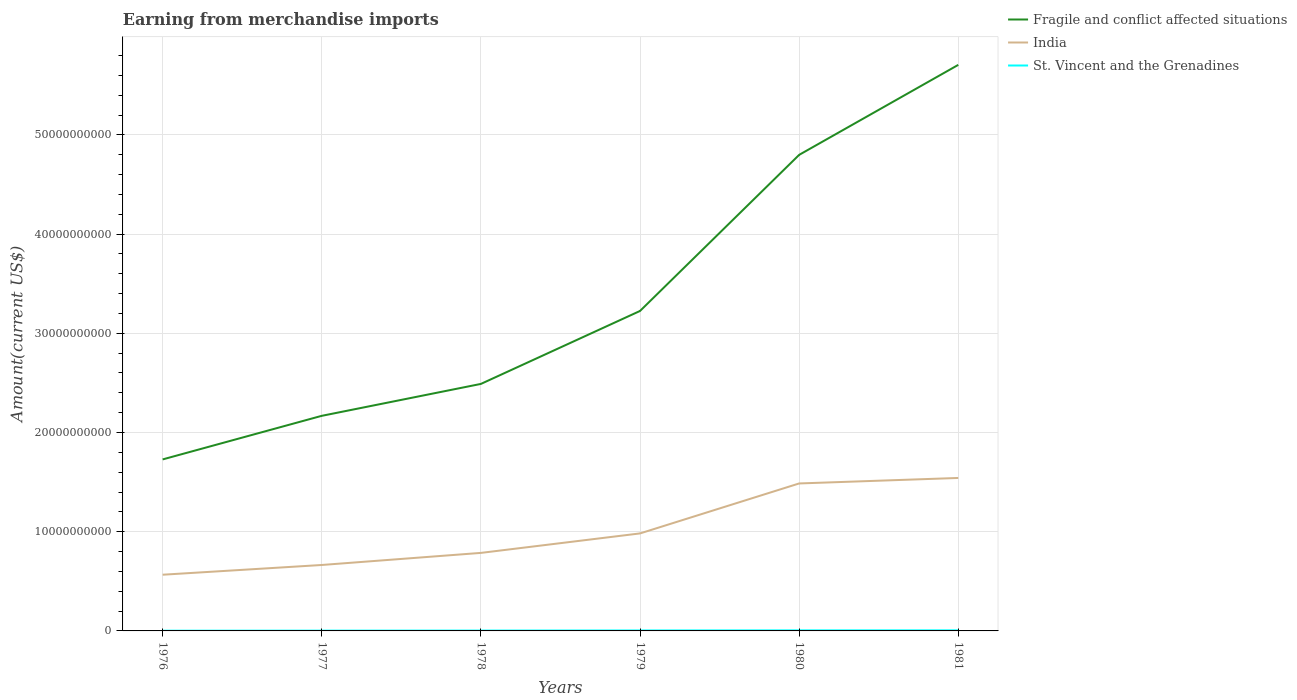Does the line corresponding to St. Vincent and the Grenadines intersect with the line corresponding to India?
Your response must be concise. No. Is the number of lines equal to the number of legend labels?
Provide a succinct answer. Yes. Across all years, what is the maximum amount earned from merchandise imports in St. Vincent and the Grenadines?
Provide a succinct answer. 2.37e+07. In which year was the amount earned from merchandise imports in India maximum?
Make the answer very short. 1976. What is the total amount earned from merchandise imports in St. Vincent and the Grenadines in the graph?
Your response must be concise. -2.77e+07. What is the difference between the highest and the second highest amount earned from merchandise imports in St. Vincent and the Grenadines?
Offer a terse response. 3.43e+07. How many lines are there?
Give a very brief answer. 3. How many years are there in the graph?
Offer a very short reply. 6. Are the values on the major ticks of Y-axis written in scientific E-notation?
Make the answer very short. No. Where does the legend appear in the graph?
Give a very brief answer. Top right. How many legend labels are there?
Offer a terse response. 3. What is the title of the graph?
Your answer should be compact. Earning from merchandise imports. Does "Poland" appear as one of the legend labels in the graph?
Offer a terse response. No. What is the label or title of the Y-axis?
Give a very brief answer. Amount(current US$). What is the Amount(current US$) of Fragile and conflict affected situations in 1976?
Your response must be concise. 1.73e+1. What is the Amount(current US$) of India in 1976?
Offer a very short reply. 5.66e+09. What is the Amount(current US$) of St. Vincent and the Grenadines in 1976?
Your answer should be very brief. 2.37e+07. What is the Amount(current US$) in Fragile and conflict affected situations in 1977?
Give a very brief answer. 2.17e+1. What is the Amount(current US$) of India in 1977?
Make the answer very short. 6.65e+09. What is the Amount(current US$) in St. Vincent and the Grenadines in 1977?
Your answer should be compact. 3.03e+07. What is the Amount(current US$) of Fragile and conflict affected situations in 1978?
Your response must be concise. 2.49e+1. What is the Amount(current US$) of India in 1978?
Provide a succinct answer. 7.86e+09. What is the Amount(current US$) in St. Vincent and the Grenadines in 1978?
Your response must be concise. 3.62e+07. What is the Amount(current US$) of Fragile and conflict affected situations in 1979?
Provide a succinct answer. 3.23e+1. What is the Amount(current US$) in India in 1979?
Your answer should be compact. 9.83e+09. What is the Amount(current US$) in St. Vincent and the Grenadines in 1979?
Provide a succinct answer. 4.66e+07. What is the Amount(current US$) of Fragile and conflict affected situations in 1980?
Make the answer very short. 4.80e+1. What is the Amount(current US$) in India in 1980?
Give a very brief answer. 1.49e+1. What is the Amount(current US$) of St. Vincent and the Grenadines in 1980?
Give a very brief answer. 5.70e+07. What is the Amount(current US$) of Fragile and conflict affected situations in 1981?
Make the answer very short. 5.71e+1. What is the Amount(current US$) in India in 1981?
Offer a terse response. 1.54e+1. What is the Amount(current US$) of St. Vincent and the Grenadines in 1981?
Your response must be concise. 5.80e+07. Across all years, what is the maximum Amount(current US$) of Fragile and conflict affected situations?
Provide a short and direct response. 5.71e+1. Across all years, what is the maximum Amount(current US$) in India?
Your answer should be very brief. 1.54e+1. Across all years, what is the maximum Amount(current US$) in St. Vincent and the Grenadines?
Provide a succinct answer. 5.80e+07. Across all years, what is the minimum Amount(current US$) in Fragile and conflict affected situations?
Your answer should be compact. 1.73e+1. Across all years, what is the minimum Amount(current US$) in India?
Keep it short and to the point. 5.66e+09. Across all years, what is the minimum Amount(current US$) of St. Vincent and the Grenadines?
Provide a short and direct response. 2.37e+07. What is the total Amount(current US$) in Fragile and conflict affected situations in the graph?
Offer a very short reply. 2.01e+11. What is the total Amount(current US$) of India in the graph?
Ensure brevity in your answer.  6.03e+1. What is the total Amount(current US$) in St. Vincent and the Grenadines in the graph?
Keep it short and to the point. 2.52e+08. What is the difference between the Amount(current US$) of Fragile and conflict affected situations in 1976 and that in 1977?
Provide a succinct answer. -4.39e+09. What is the difference between the Amount(current US$) of India in 1976 and that in 1977?
Provide a succinct answer. -9.82e+08. What is the difference between the Amount(current US$) of St. Vincent and the Grenadines in 1976 and that in 1977?
Ensure brevity in your answer.  -6.61e+06. What is the difference between the Amount(current US$) in Fragile and conflict affected situations in 1976 and that in 1978?
Your response must be concise. -7.61e+09. What is the difference between the Amount(current US$) in India in 1976 and that in 1978?
Give a very brief answer. -2.20e+09. What is the difference between the Amount(current US$) of St. Vincent and the Grenadines in 1976 and that in 1978?
Ensure brevity in your answer.  -1.25e+07. What is the difference between the Amount(current US$) of Fragile and conflict affected situations in 1976 and that in 1979?
Make the answer very short. -1.50e+1. What is the difference between the Amount(current US$) of India in 1976 and that in 1979?
Keep it short and to the point. -4.16e+09. What is the difference between the Amount(current US$) of St. Vincent and the Grenadines in 1976 and that in 1979?
Make the answer very short. -2.29e+07. What is the difference between the Amount(current US$) in Fragile and conflict affected situations in 1976 and that in 1980?
Provide a short and direct response. -3.07e+1. What is the difference between the Amount(current US$) of India in 1976 and that in 1980?
Give a very brief answer. -9.20e+09. What is the difference between the Amount(current US$) in St. Vincent and the Grenadines in 1976 and that in 1980?
Your answer should be very brief. -3.33e+07. What is the difference between the Amount(current US$) of Fragile and conflict affected situations in 1976 and that in 1981?
Keep it short and to the point. -3.98e+1. What is the difference between the Amount(current US$) in India in 1976 and that in 1981?
Make the answer very short. -9.75e+09. What is the difference between the Amount(current US$) of St. Vincent and the Grenadines in 1976 and that in 1981?
Your answer should be very brief. -3.43e+07. What is the difference between the Amount(current US$) in Fragile and conflict affected situations in 1977 and that in 1978?
Provide a succinct answer. -3.22e+09. What is the difference between the Amount(current US$) of India in 1977 and that in 1978?
Make the answer very short. -1.22e+09. What is the difference between the Amount(current US$) of St. Vincent and the Grenadines in 1977 and that in 1978?
Offer a terse response. -5.85e+06. What is the difference between the Amount(current US$) in Fragile and conflict affected situations in 1977 and that in 1979?
Your answer should be compact. -1.06e+1. What is the difference between the Amount(current US$) of India in 1977 and that in 1979?
Make the answer very short. -3.18e+09. What is the difference between the Amount(current US$) of St. Vincent and the Grenadines in 1977 and that in 1979?
Offer a terse response. -1.63e+07. What is the difference between the Amount(current US$) in Fragile and conflict affected situations in 1977 and that in 1980?
Ensure brevity in your answer.  -2.63e+1. What is the difference between the Amount(current US$) of India in 1977 and that in 1980?
Give a very brief answer. -8.22e+09. What is the difference between the Amount(current US$) of St. Vincent and the Grenadines in 1977 and that in 1980?
Give a very brief answer. -2.67e+07. What is the difference between the Amount(current US$) of Fragile and conflict affected situations in 1977 and that in 1981?
Your answer should be very brief. -3.54e+1. What is the difference between the Amount(current US$) in India in 1977 and that in 1981?
Provide a succinct answer. -8.77e+09. What is the difference between the Amount(current US$) of St. Vincent and the Grenadines in 1977 and that in 1981?
Offer a terse response. -2.77e+07. What is the difference between the Amount(current US$) in Fragile and conflict affected situations in 1978 and that in 1979?
Provide a succinct answer. -7.35e+09. What is the difference between the Amount(current US$) of India in 1978 and that in 1979?
Make the answer very short. -1.96e+09. What is the difference between the Amount(current US$) of St. Vincent and the Grenadines in 1978 and that in 1979?
Your answer should be compact. -1.04e+07. What is the difference between the Amount(current US$) in Fragile and conflict affected situations in 1978 and that in 1980?
Ensure brevity in your answer.  -2.31e+1. What is the difference between the Amount(current US$) of India in 1978 and that in 1980?
Give a very brief answer. -7.00e+09. What is the difference between the Amount(current US$) of St. Vincent and the Grenadines in 1978 and that in 1980?
Keep it short and to the point. -2.08e+07. What is the difference between the Amount(current US$) in Fragile and conflict affected situations in 1978 and that in 1981?
Provide a short and direct response. -3.22e+1. What is the difference between the Amount(current US$) in India in 1978 and that in 1981?
Provide a succinct answer. -7.55e+09. What is the difference between the Amount(current US$) in St. Vincent and the Grenadines in 1978 and that in 1981?
Ensure brevity in your answer.  -2.18e+07. What is the difference between the Amount(current US$) in Fragile and conflict affected situations in 1979 and that in 1980?
Ensure brevity in your answer.  -1.57e+1. What is the difference between the Amount(current US$) of India in 1979 and that in 1980?
Make the answer very short. -5.04e+09. What is the difference between the Amount(current US$) in St. Vincent and the Grenadines in 1979 and that in 1980?
Your response must be concise. -1.04e+07. What is the difference between the Amount(current US$) of Fragile and conflict affected situations in 1979 and that in 1981?
Keep it short and to the point. -2.48e+1. What is the difference between the Amount(current US$) in India in 1979 and that in 1981?
Your answer should be compact. -5.59e+09. What is the difference between the Amount(current US$) in St. Vincent and the Grenadines in 1979 and that in 1981?
Offer a terse response. -1.14e+07. What is the difference between the Amount(current US$) in Fragile and conflict affected situations in 1980 and that in 1981?
Provide a succinct answer. -9.07e+09. What is the difference between the Amount(current US$) of India in 1980 and that in 1981?
Your response must be concise. -5.54e+08. What is the difference between the Amount(current US$) of St. Vincent and the Grenadines in 1980 and that in 1981?
Offer a very short reply. -1.00e+06. What is the difference between the Amount(current US$) of Fragile and conflict affected situations in 1976 and the Amount(current US$) of India in 1977?
Provide a short and direct response. 1.06e+1. What is the difference between the Amount(current US$) of Fragile and conflict affected situations in 1976 and the Amount(current US$) of St. Vincent and the Grenadines in 1977?
Provide a succinct answer. 1.73e+1. What is the difference between the Amount(current US$) in India in 1976 and the Amount(current US$) in St. Vincent and the Grenadines in 1977?
Offer a terse response. 5.63e+09. What is the difference between the Amount(current US$) of Fragile and conflict affected situations in 1976 and the Amount(current US$) of India in 1978?
Offer a terse response. 9.42e+09. What is the difference between the Amount(current US$) of Fragile and conflict affected situations in 1976 and the Amount(current US$) of St. Vincent and the Grenadines in 1978?
Offer a very short reply. 1.73e+1. What is the difference between the Amount(current US$) in India in 1976 and the Amount(current US$) in St. Vincent and the Grenadines in 1978?
Make the answer very short. 5.63e+09. What is the difference between the Amount(current US$) in Fragile and conflict affected situations in 1976 and the Amount(current US$) in India in 1979?
Your answer should be very brief. 7.46e+09. What is the difference between the Amount(current US$) in Fragile and conflict affected situations in 1976 and the Amount(current US$) in St. Vincent and the Grenadines in 1979?
Provide a short and direct response. 1.72e+1. What is the difference between the Amount(current US$) of India in 1976 and the Amount(current US$) of St. Vincent and the Grenadines in 1979?
Keep it short and to the point. 5.62e+09. What is the difference between the Amount(current US$) of Fragile and conflict affected situations in 1976 and the Amount(current US$) of India in 1980?
Give a very brief answer. 2.42e+09. What is the difference between the Amount(current US$) of Fragile and conflict affected situations in 1976 and the Amount(current US$) of St. Vincent and the Grenadines in 1980?
Your response must be concise. 1.72e+1. What is the difference between the Amount(current US$) in India in 1976 and the Amount(current US$) in St. Vincent and the Grenadines in 1980?
Ensure brevity in your answer.  5.61e+09. What is the difference between the Amount(current US$) of Fragile and conflict affected situations in 1976 and the Amount(current US$) of India in 1981?
Offer a very short reply. 1.87e+09. What is the difference between the Amount(current US$) of Fragile and conflict affected situations in 1976 and the Amount(current US$) of St. Vincent and the Grenadines in 1981?
Ensure brevity in your answer.  1.72e+1. What is the difference between the Amount(current US$) of India in 1976 and the Amount(current US$) of St. Vincent and the Grenadines in 1981?
Ensure brevity in your answer.  5.61e+09. What is the difference between the Amount(current US$) of Fragile and conflict affected situations in 1977 and the Amount(current US$) of India in 1978?
Your answer should be compact. 1.38e+1. What is the difference between the Amount(current US$) in Fragile and conflict affected situations in 1977 and the Amount(current US$) in St. Vincent and the Grenadines in 1978?
Keep it short and to the point. 2.16e+1. What is the difference between the Amount(current US$) of India in 1977 and the Amount(current US$) of St. Vincent and the Grenadines in 1978?
Provide a succinct answer. 6.61e+09. What is the difference between the Amount(current US$) in Fragile and conflict affected situations in 1977 and the Amount(current US$) in India in 1979?
Your answer should be very brief. 1.19e+1. What is the difference between the Amount(current US$) in Fragile and conflict affected situations in 1977 and the Amount(current US$) in St. Vincent and the Grenadines in 1979?
Keep it short and to the point. 2.16e+1. What is the difference between the Amount(current US$) of India in 1977 and the Amount(current US$) of St. Vincent and the Grenadines in 1979?
Your answer should be very brief. 6.60e+09. What is the difference between the Amount(current US$) of Fragile and conflict affected situations in 1977 and the Amount(current US$) of India in 1980?
Your answer should be compact. 6.82e+09. What is the difference between the Amount(current US$) in Fragile and conflict affected situations in 1977 and the Amount(current US$) in St. Vincent and the Grenadines in 1980?
Your answer should be compact. 2.16e+1. What is the difference between the Amount(current US$) of India in 1977 and the Amount(current US$) of St. Vincent and the Grenadines in 1980?
Give a very brief answer. 6.59e+09. What is the difference between the Amount(current US$) in Fragile and conflict affected situations in 1977 and the Amount(current US$) in India in 1981?
Make the answer very short. 6.26e+09. What is the difference between the Amount(current US$) of Fragile and conflict affected situations in 1977 and the Amount(current US$) of St. Vincent and the Grenadines in 1981?
Make the answer very short. 2.16e+1. What is the difference between the Amount(current US$) in India in 1977 and the Amount(current US$) in St. Vincent and the Grenadines in 1981?
Provide a succinct answer. 6.59e+09. What is the difference between the Amount(current US$) of Fragile and conflict affected situations in 1978 and the Amount(current US$) of India in 1979?
Your answer should be very brief. 1.51e+1. What is the difference between the Amount(current US$) in Fragile and conflict affected situations in 1978 and the Amount(current US$) in St. Vincent and the Grenadines in 1979?
Make the answer very short. 2.49e+1. What is the difference between the Amount(current US$) in India in 1978 and the Amount(current US$) in St. Vincent and the Grenadines in 1979?
Offer a terse response. 7.82e+09. What is the difference between the Amount(current US$) of Fragile and conflict affected situations in 1978 and the Amount(current US$) of India in 1980?
Offer a terse response. 1.00e+1. What is the difference between the Amount(current US$) in Fragile and conflict affected situations in 1978 and the Amount(current US$) in St. Vincent and the Grenadines in 1980?
Give a very brief answer. 2.48e+1. What is the difference between the Amount(current US$) of India in 1978 and the Amount(current US$) of St. Vincent and the Grenadines in 1980?
Offer a terse response. 7.81e+09. What is the difference between the Amount(current US$) of Fragile and conflict affected situations in 1978 and the Amount(current US$) of India in 1981?
Offer a terse response. 9.48e+09. What is the difference between the Amount(current US$) of Fragile and conflict affected situations in 1978 and the Amount(current US$) of St. Vincent and the Grenadines in 1981?
Make the answer very short. 2.48e+1. What is the difference between the Amount(current US$) of India in 1978 and the Amount(current US$) of St. Vincent and the Grenadines in 1981?
Ensure brevity in your answer.  7.81e+09. What is the difference between the Amount(current US$) in Fragile and conflict affected situations in 1979 and the Amount(current US$) in India in 1980?
Your answer should be very brief. 1.74e+1. What is the difference between the Amount(current US$) in Fragile and conflict affected situations in 1979 and the Amount(current US$) in St. Vincent and the Grenadines in 1980?
Your answer should be compact. 3.22e+1. What is the difference between the Amount(current US$) of India in 1979 and the Amount(current US$) of St. Vincent and the Grenadines in 1980?
Your answer should be compact. 9.77e+09. What is the difference between the Amount(current US$) of Fragile and conflict affected situations in 1979 and the Amount(current US$) of India in 1981?
Offer a terse response. 1.68e+1. What is the difference between the Amount(current US$) in Fragile and conflict affected situations in 1979 and the Amount(current US$) in St. Vincent and the Grenadines in 1981?
Provide a short and direct response. 3.22e+1. What is the difference between the Amount(current US$) of India in 1979 and the Amount(current US$) of St. Vincent and the Grenadines in 1981?
Your answer should be compact. 9.77e+09. What is the difference between the Amount(current US$) of Fragile and conflict affected situations in 1980 and the Amount(current US$) of India in 1981?
Keep it short and to the point. 3.26e+1. What is the difference between the Amount(current US$) in Fragile and conflict affected situations in 1980 and the Amount(current US$) in St. Vincent and the Grenadines in 1981?
Give a very brief answer. 4.79e+1. What is the difference between the Amount(current US$) of India in 1980 and the Amount(current US$) of St. Vincent and the Grenadines in 1981?
Offer a terse response. 1.48e+1. What is the average Amount(current US$) in Fragile and conflict affected situations per year?
Offer a terse response. 3.35e+1. What is the average Amount(current US$) of India per year?
Give a very brief answer. 1.00e+1. What is the average Amount(current US$) in St. Vincent and the Grenadines per year?
Make the answer very short. 4.20e+07. In the year 1976, what is the difference between the Amount(current US$) in Fragile and conflict affected situations and Amount(current US$) in India?
Ensure brevity in your answer.  1.16e+1. In the year 1976, what is the difference between the Amount(current US$) in Fragile and conflict affected situations and Amount(current US$) in St. Vincent and the Grenadines?
Offer a terse response. 1.73e+1. In the year 1976, what is the difference between the Amount(current US$) of India and Amount(current US$) of St. Vincent and the Grenadines?
Offer a very short reply. 5.64e+09. In the year 1977, what is the difference between the Amount(current US$) in Fragile and conflict affected situations and Amount(current US$) in India?
Provide a succinct answer. 1.50e+1. In the year 1977, what is the difference between the Amount(current US$) of Fragile and conflict affected situations and Amount(current US$) of St. Vincent and the Grenadines?
Offer a very short reply. 2.17e+1. In the year 1977, what is the difference between the Amount(current US$) of India and Amount(current US$) of St. Vincent and the Grenadines?
Your answer should be very brief. 6.62e+09. In the year 1978, what is the difference between the Amount(current US$) of Fragile and conflict affected situations and Amount(current US$) of India?
Keep it short and to the point. 1.70e+1. In the year 1978, what is the difference between the Amount(current US$) in Fragile and conflict affected situations and Amount(current US$) in St. Vincent and the Grenadines?
Keep it short and to the point. 2.49e+1. In the year 1978, what is the difference between the Amount(current US$) of India and Amount(current US$) of St. Vincent and the Grenadines?
Keep it short and to the point. 7.83e+09. In the year 1979, what is the difference between the Amount(current US$) in Fragile and conflict affected situations and Amount(current US$) in India?
Your answer should be compact. 2.24e+1. In the year 1979, what is the difference between the Amount(current US$) of Fragile and conflict affected situations and Amount(current US$) of St. Vincent and the Grenadines?
Keep it short and to the point. 3.22e+1. In the year 1979, what is the difference between the Amount(current US$) of India and Amount(current US$) of St. Vincent and the Grenadines?
Keep it short and to the point. 9.78e+09. In the year 1980, what is the difference between the Amount(current US$) of Fragile and conflict affected situations and Amount(current US$) of India?
Make the answer very short. 3.31e+1. In the year 1980, what is the difference between the Amount(current US$) in Fragile and conflict affected situations and Amount(current US$) in St. Vincent and the Grenadines?
Make the answer very short. 4.79e+1. In the year 1980, what is the difference between the Amount(current US$) in India and Amount(current US$) in St. Vincent and the Grenadines?
Keep it short and to the point. 1.48e+1. In the year 1981, what is the difference between the Amount(current US$) in Fragile and conflict affected situations and Amount(current US$) in India?
Offer a very short reply. 4.16e+1. In the year 1981, what is the difference between the Amount(current US$) of Fragile and conflict affected situations and Amount(current US$) of St. Vincent and the Grenadines?
Your answer should be compact. 5.70e+1. In the year 1981, what is the difference between the Amount(current US$) of India and Amount(current US$) of St. Vincent and the Grenadines?
Your answer should be compact. 1.54e+1. What is the ratio of the Amount(current US$) of Fragile and conflict affected situations in 1976 to that in 1977?
Your response must be concise. 0.8. What is the ratio of the Amount(current US$) of India in 1976 to that in 1977?
Make the answer very short. 0.85. What is the ratio of the Amount(current US$) of St. Vincent and the Grenadines in 1976 to that in 1977?
Ensure brevity in your answer.  0.78. What is the ratio of the Amount(current US$) in Fragile and conflict affected situations in 1976 to that in 1978?
Give a very brief answer. 0.69. What is the ratio of the Amount(current US$) of India in 1976 to that in 1978?
Provide a succinct answer. 0.72. What is the ratio of the Amount(current US$) in St. Vincent and the Grenadines in 1976 to that in 1978?
Give a very brief answer. 0.66. What is the ratio of the Amount(current US$) of Fragile and conflict affected situations in 1976 to that in 1979?
Make the answer very short. 0.54. What is the ratio of the Amount(current US$) of India in 1976 to that in 1979?
Your answer should be very brief. 0.58. What is the ratio of the Amount(current US$) of St. Vincent and the Grenadines in 1976 to that in 1979?
Offer a terse response. 0.51. What is the ratio of the Amount(current US$) of Fragile and conflict affected situations in 1976 to that in 1980?
Make the answer very short. 0.36. What is the ratio of the Amount(current US$) in India in 1976 to that in 1980?
Ensure brevity in your answer.  0.38. What is the ratio of the Amount(current US$) in St. Vincent and the Grenadines in 1976 to that in 1980?
Your response must be concise. 0.42. What is the ratio of the Amount(current US$) of Fragile and conflict affected situations in 1976 to that in 1981?
Offer a terse response. 0.3. What is the ratio of the Amount(current US$) in India in 1976 to that in 1981?
Make the answer very short. 0.37. What is the ratio of the Amount(current US$) of St. Vincent and the Grenadines in 1976 to that in 1981?
Give a very brief answer. 0.41. What is the ratio of the Amount(current US$) of Fragile and conflict affected situations in 1977 to that in 1978?
Your answer should be very brief. 0.87. What is the ratio of the Amount(current US$) in India in 1977 to that in 1978?
Give a very brief answer. 0.85. What is the ratio of the Amount(current US$) in St. Vincent and the Grenadines in 1977 to that in 1978?
Your response must be concise. 0.84. What is the ratio of the Amount(current US$) of Fragile and conflict affected situations in 1977 to that in 1979?
Make the answer very short. 0.67. What is the ratio of the Amount(current US$) in India in 1977 to that in 1979?
Give a very brief answer. 0.68. What is the ratio of the Amount(current US$) in St. Vincent and the Grenadines in 1977 to that in 1979?
Keep it short and to the point. 0.65. What is the ratio of the Amount(current US$) of Fragile and conflict affected situations in 1977 to that in 1980?
Give a very brief answer. 0.45. What is the ratio of the Amount(current US$) of India in 1977 to that in 1980?
Ensure brevity in your answer.  0.45. What is the ratio of the Amount(current US$) of St. Vincent and the Grenadines in 1977 to that in 1980?
Ensure brevity in your answer.  0.53. What is the ratio of the Amount(current US$) in Fragile and conflict affected situations in 1977 to that in 1981?
Offer a very short reply. 0.38. What is the ratio of the Amount(current US$) of India in 1977 to that in 1981?
Provide a short and direct response. 0.43. What is the ratio of the Amount(current US$) in St. Vincent and the Grenadines in 1977 to that in 1981?
Offer a very short reply. 0.52. What is the ratio of the Amount(current US$) of Fragile and conflict affected situations in 1978 to that in 1979?
Ensure brevity in your answer.  0.77. What is the ratio of the Amount(current US$) of India in 1978 to that in 1979?
Your answer should be very brief. 0.8. What is the ratio of the Amount(current US$) in St. Vincent and the Grenadines in 1978 to that in 1979?
Give a very brief answer. 0.78. What is the ratio of the Amount(current US$) of Fragile and conflict affected situations in 1978 to that in 1980?
Provide a succinct answer. 0.52. What is the ratio of the Amount(current US$) of India in 1978 to that in 1980?
Give a very brief answer. 0.53. What is the ratio of the Amount(current US$) in St. Vincent and the Grenadines in 1978 to that in 1980?
Offer a very short reply. 0.63. What is the ratio of the Amount(current US$) in Fragile and conflict affected situations in 1978 to that in 1981?
Provide a short and direct response. 0.44. What is the ratio of the Amount(current US$) in India in 1978 to that in 1981?
Provide a short and direct response. 0.51. What is the ratio of the Amount(current US$) in St. Vincent and the Grenadines in 1978 to that in 1981?
Provide a succinct answer. 0.62. What is the ratio of the Amount(current US$) of Fragile and conflict affected situations in 1979 to that in 1980?
Your answer should be very brief. 0.67. What is the ratio of the Amount(current US$) in India in 1979 to that in 1980?
Your answer should be very brief. 0.66. What is the ratio of the Amount(current US$) of St. Vincent and the Grenadines in 1979 to that in 1980?
Offer a terse response. 0.82. What is the ratio of the Amount(current US$) in Fragile and conflict affected situations in 1979 to that in 1981?
Provide a short and direct response. 0.57. What is the ratio of the Amount(current US$) of India in 1979 to that in 1981?
Provide a succinct answer. 0.64. What is the ratio of the Amount(current US$) in St. Vincent and the Grenadines in 1979 to that in 1981?
Make the answer very short. 0.8. What is the ratio of the Amount(current US$) of Fragile and conflict affected situations in 1980 to that in 1981?
Make the answer very short. 0.84. What is the ratio of the Amount(current US$) of India in 1980 to that in 1981?
Ensure brevity in your answer.  0.96. What is the ratio of the Amount(current US$) in St. Vincent and the Grenadines in 1980 to that in 1981?
Provide a succinct answer. 0.98. What is the difference between the highest and the second highest Amount(current US$) of Fragile and conflict affected situations?
Give a very brief answer. 9.07e+09. What is the difference between the highest and the second highest Amount(current US$) of India?
Provide a succinct answer. 5.54e+08. What is the difference between the highest and the lowest Amount(current US$) in Fragile and conflict affected situations?
Your answer should be very brief. 3.98e+1. What is the difference between the highest and the lowest Amount(current US$) of India?
Keep it short and to the point. 9.75e+09. What is the difference between the highest and the lowest Amount(current US$) of St. Vincent and the Grenadines?
Keep it short and to the point. 3.43e+07. 